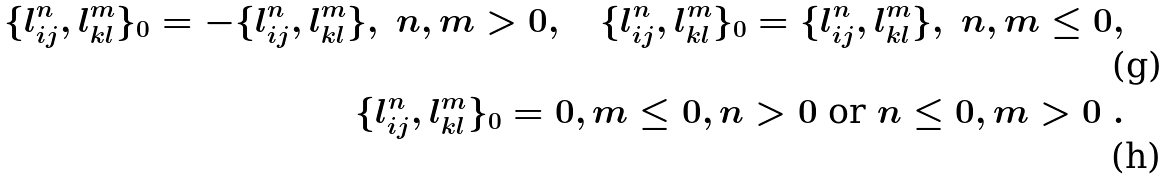Convert formula to latex. <formula><loc_0><loc_0><loc_500><loc_500>\{ l ^ { n } _ { i j } , l ^ { m } _ { k l } \} _ { 0 } = - \{ l ^ { n } _ { i j } , l ^ { m } _ { k l } \} , \ n , m > 0 , \quad \{ l ^ { n } _ { i j } , l ^ { m } _ { k l } \} _ { 0 } = \{ l ^ { n } _ { i j } , l ^ { m } _ { k l } \} , \ n , m \leq 0 , \\ \{ l ^ { n } _ { i j } , l ^ { m } _ { k l } \} _ { 0 } = 0 , m \leq 0 , n > 0 \ \text {or} \ n \leq 0 , m > 0 \ .</formula> 